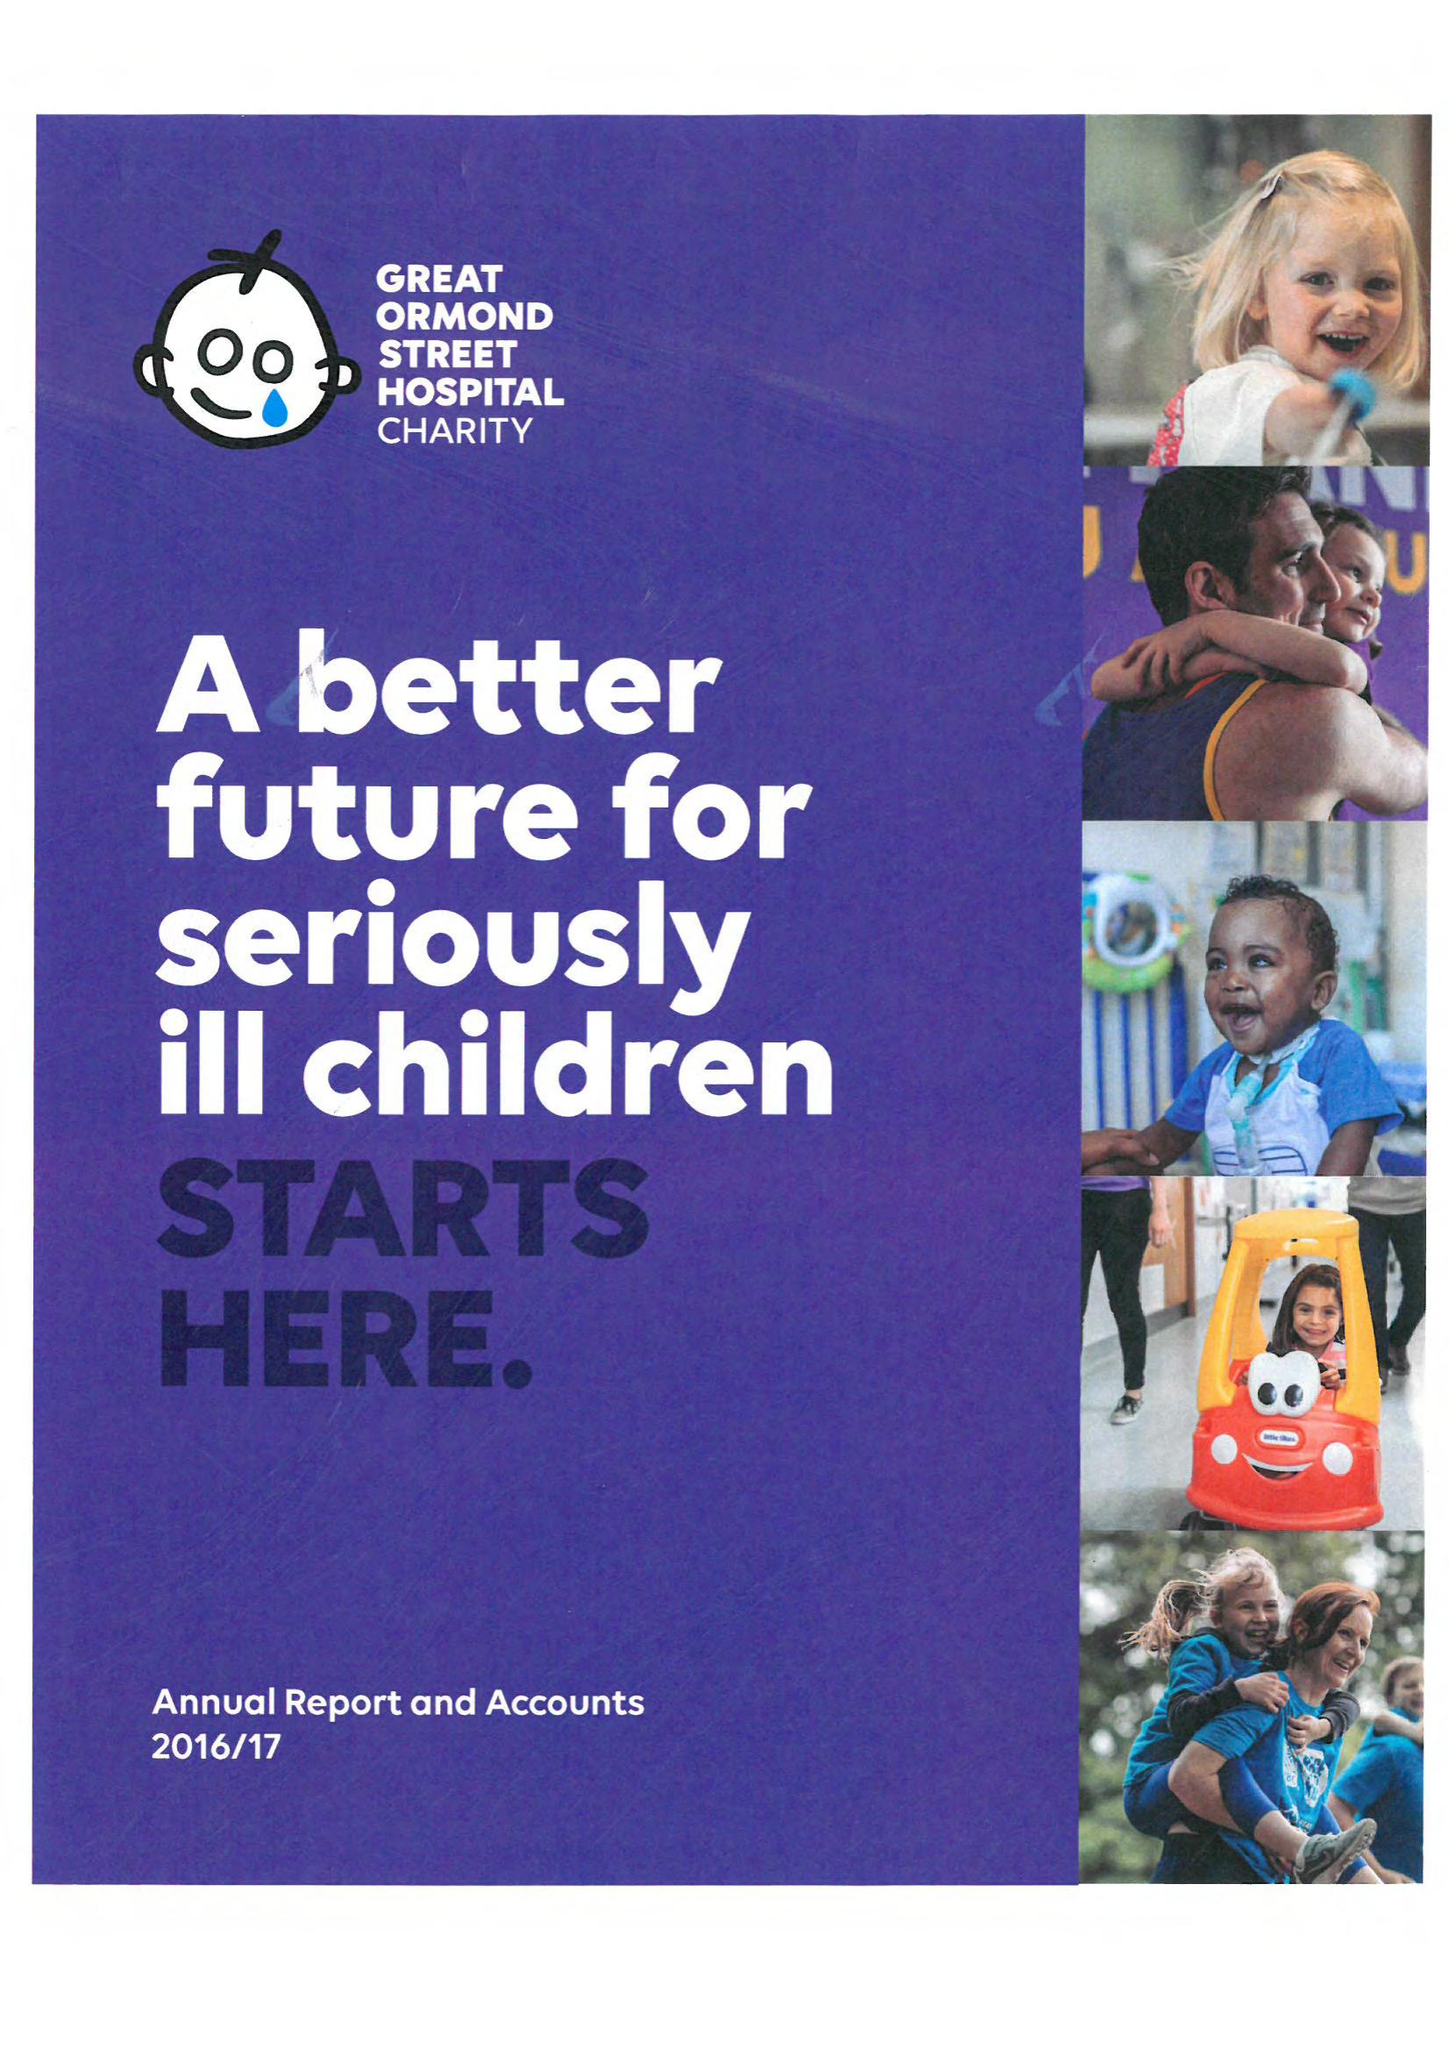What is the value for the charity_name?
Answer the question using a single word or phrase. Great Ormond Street Hospital Children's Charity 